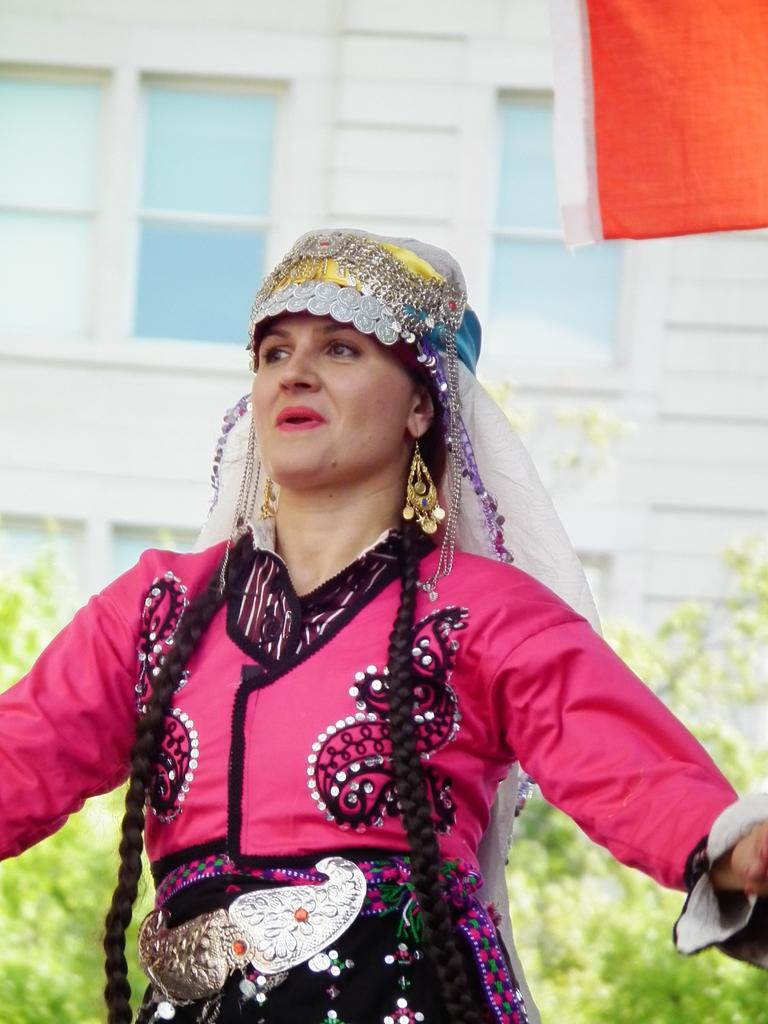Who or what is the main subject in the image? There is a person in the image. What is the person wearing? The person is wearing a pink dress. What type of accessory can be seen on the person? The person has golden earrings. What can be seen in the background of the image? There are plants and a building with windows in the background of the image. What type of bun is being used to hold the person's hair in the image? There is no bun visible in the image; the person's hair is not mentioned in the provided facts. What type of lettuce can be seen in the person's salad in the image? There is no salad or lettuce present in the image. 